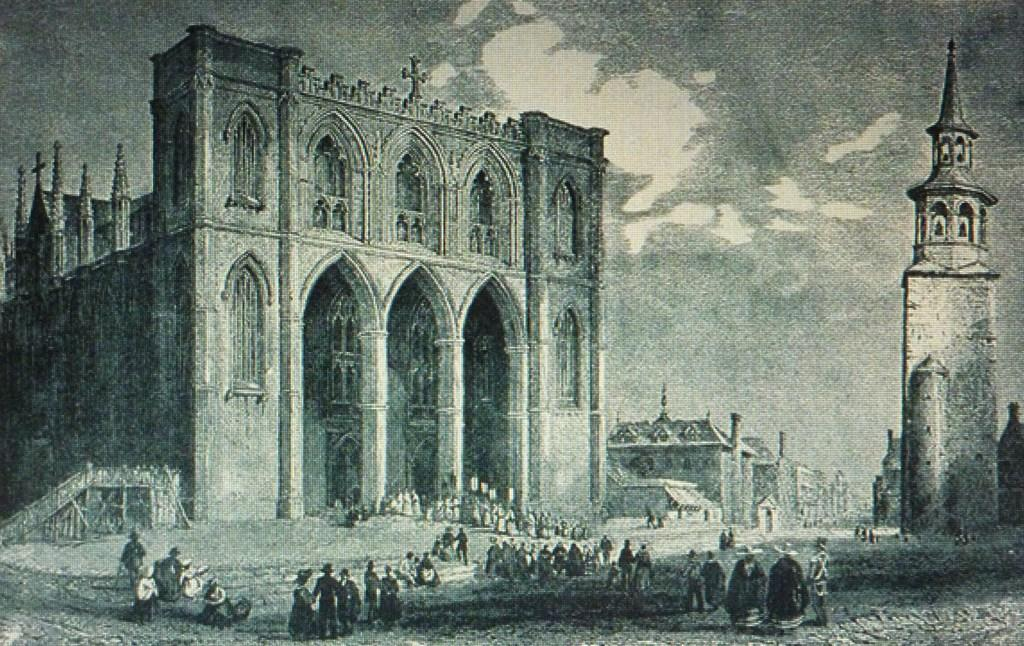What can be seen at the bottom of the image? There are people standing at the bottom of the image. What structures are located behind the people? There are buildings behind the people. What type of natural elements can be seen at the top of the image? There are clouds visible at the top of the image. What else is visible at the top of the image? The sky is visible at the top of the image. How many eggs are being cared for by the people in the image? There is no mention of eggs or any caretaking activities in the image. 